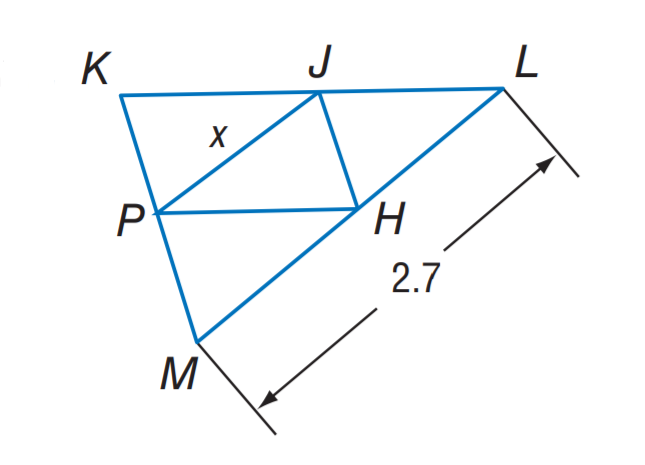Question: J H, J P, and P H are midsegments of \triangle K L M. Find x.
Choices:
A. 1.05
B. 1.35
C. 2.1
D. 2.7
Answer with the letter. Answer: B 